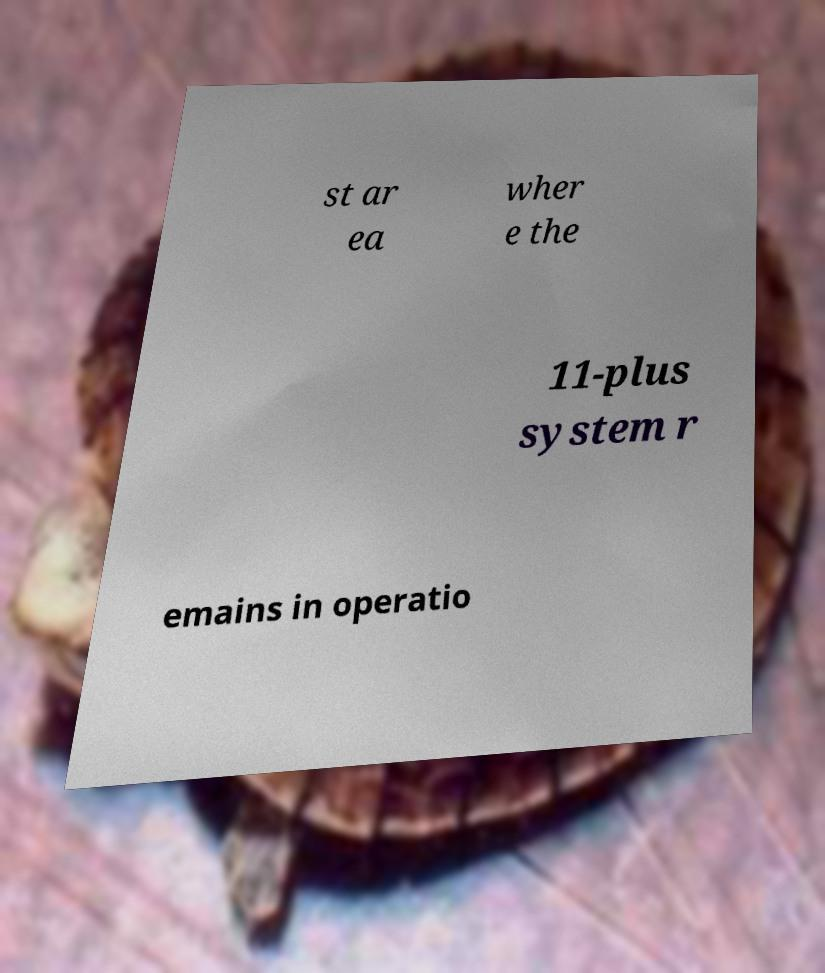I need the written content from this picture converted into text. Can you do that? st ar ea wher e the 11-plus system r emains in operatio 